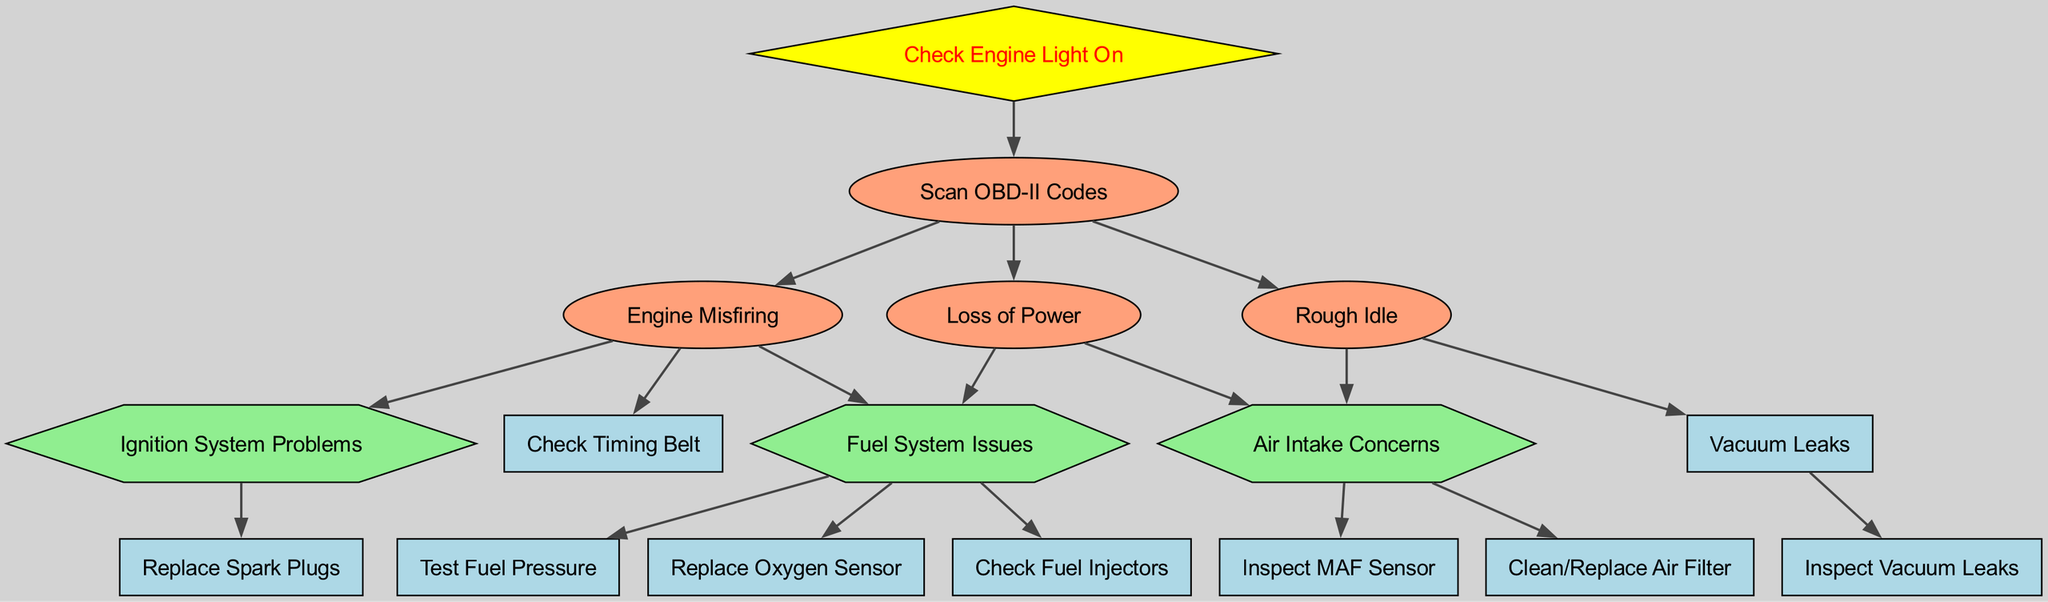What node do you start with if the check engine light is on? The diagram indicates that when the check engine light is on, the first step is to scan OBD-II codes. Therefore, the starting point is the "Scan OBD-II Codes" node.
Answer: Scan OBD-II Codes How many nodes are there in total in the diagram? By counting all the unique nodes listed, there are 15 nodes shown in the diagram.
Answer: 15 Which node comes after "Engine Misfiring"? The diagram shows that after "Engine Misfiring," the next possible nodes to consider are "Ignition System Problems" and "Fuel System Issues." Since it's looking for the immediate next node, we can reference the first step.
Answer: Ignition System Problems What type of node is "Check Engine Light On"? The diagram specifies that "Check Engine Light On" is represented as a diamond shape, which indicates that it is a decision point or a starting condition in this troubleshooting process.
Answer: Diamond If there is a rough idle, what could be the potential issues? From the diagram, a rough idle can lead to examining "Air Intake Concerns" and "Vacuum Leaks." These are the specific issues to investigate further based on that condition.
Answer: Air Intake Concerns, Vacuum Leaks How many edges lead out of "Loss of Power"? The "Loss of Power" node has two outgoing edges, pointing to "Fuel System Issues" and "Air Intake Concerns." This indicates two different paths for further diagnostics from this node.
Answer: 2 What action should be taken if "Fuel System Issues" are identified? According to the diagram, first actions to take when "Fuel System Issues" are identified include checking fuel injectors, testing fuel pressure, and possibly replacing the oxygen sensor.
Answer: Check Fuel Injectors, Test Fuel Pressure, Replace Oxygen Sensor What is the relationship between "Scan OBD-II Codes" and "Engine Misfiring"? The connection shown in the diagram indicates that "Scan OBD-II Codes" leads to detecting "Engine Misfiring" as one of the possible issues that might be identified after scanning, establishing a cause-and-effect relationship.
Answer: Leads to Which node could be the last check before concluding the issue may be in the ignition system? If diagnostics conclude that the issue lies in the ignition system, the final step directly before this conclusion would be to "Replace Spark Plugs," as indicated in the diagram following "Ignition System Problems."
Answer: Replace Spark Plugs 